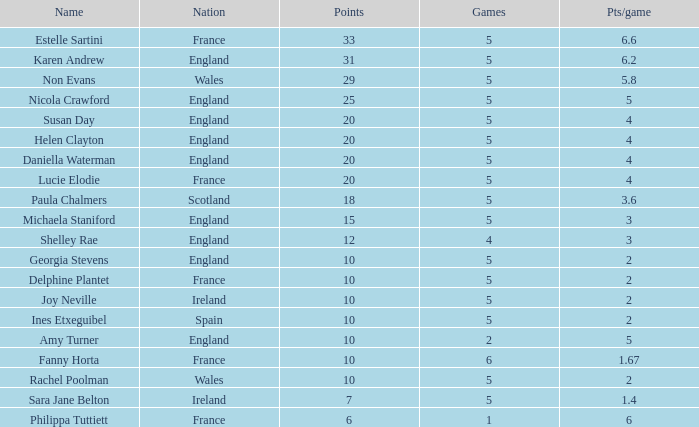Can you tell me the average Points that has a Pts/game larger than 4, and the Nation of england, and the Games smaller than 5? 10.0. 